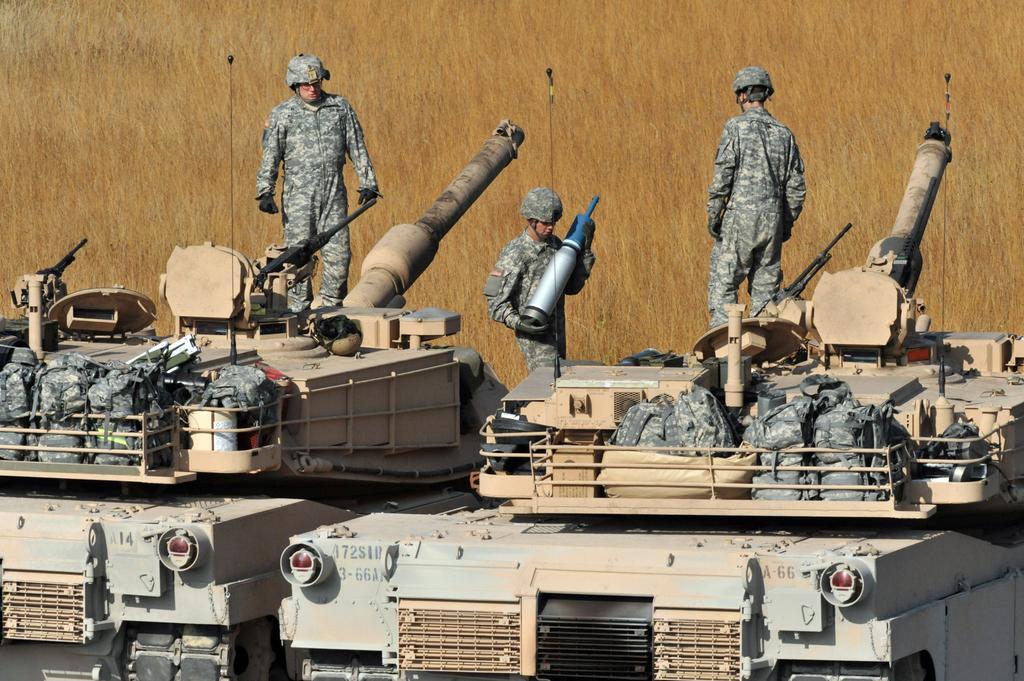How would you summarize this image in a sentence or two? In this image there are two military tankers in the middle, on which there are three military officers. There are few military bags kept at the top of the tank. The man in the middle is holding a metal rod. 